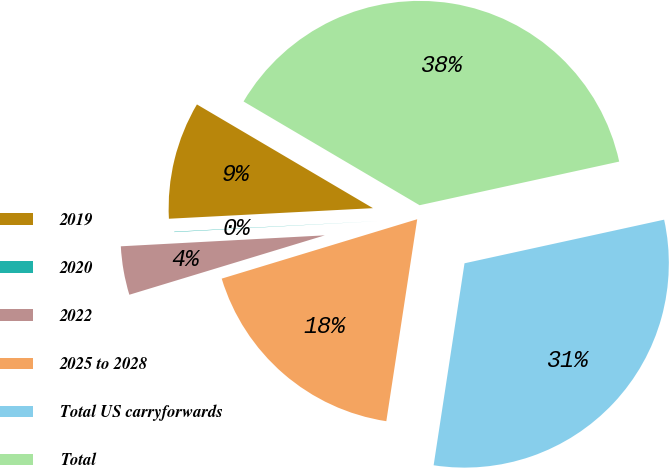Convert chart. <chart><loc_0><loc_0><loc_500><loc_500><pie_chart><fcel>2019<fcel>2020<fcel>2022<fcel>2025 to 2028<fcel>Total US carryforwards<fcel>Total<nl><fcel>9.3%<fcel>0.03%<fcel>3.84%<fcel>17.89%<fcel>30.84%<fcel>38.1%<nl></chart> 